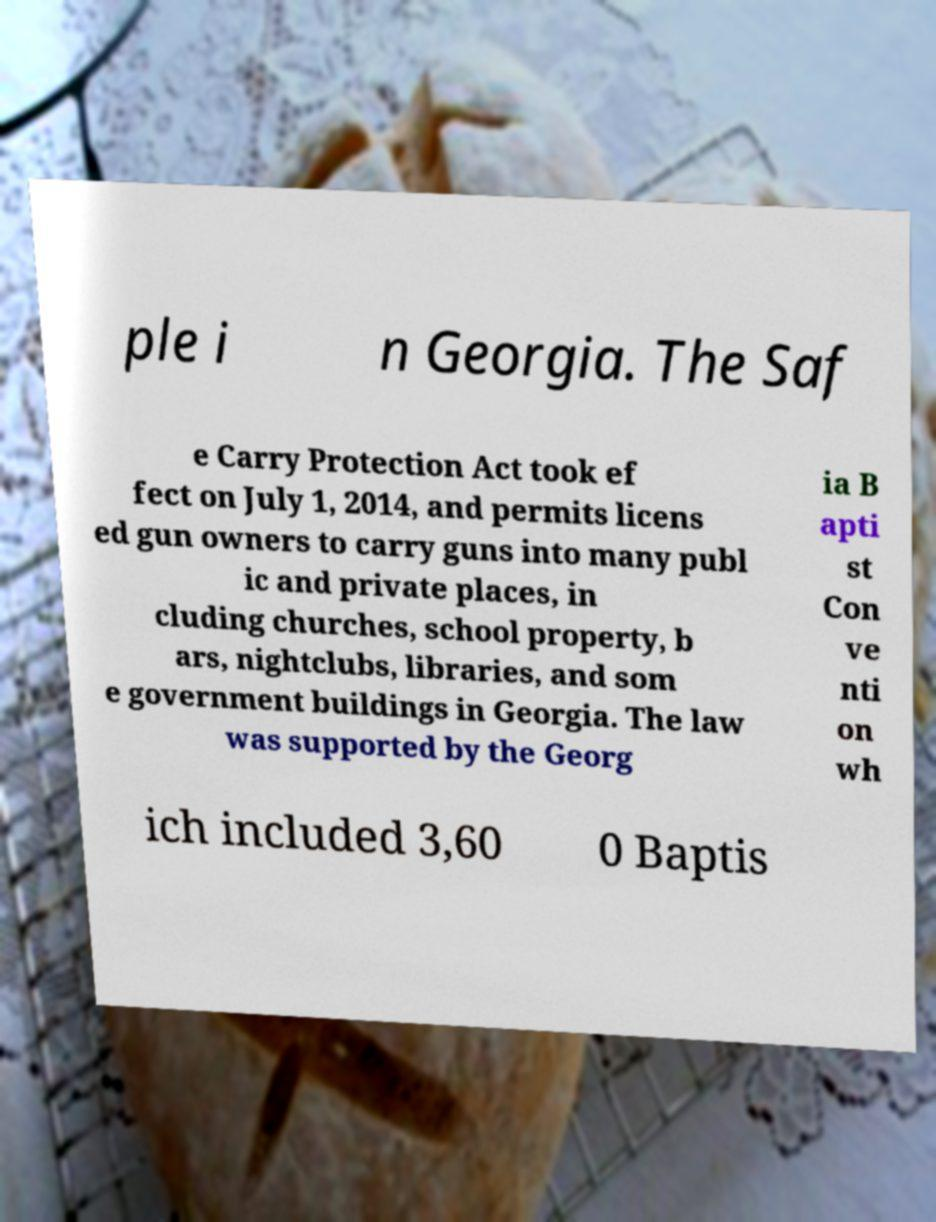I need the written content from this picture converted into text. Can you do that? ple i n Georgia. The Saf e Carry Protection Act took ef fect on July 1, 2014, and permits licens ed gun owners to carry guns into many publ ic and private places, in cluding churches, school property, b ars, nightclubs, libraries, and som e government buildings in Georgia. The law was supported by the Georg ia B apti st Con ve nti on wh ich included 3,60 0 Baptis 